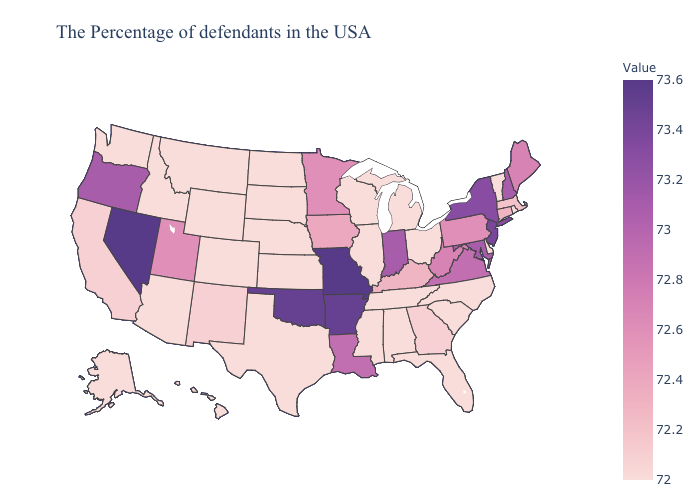Is the legend a continuous bar?
Give a very brief answer. Yes. Does Missouri have a lower value than Wisconsin?
Write a very short answer. No. Does Nebraska have a lower value than Kentucky?
Keep it brief. Yes. Which states have the lowest value in the USA?
Quick response, please. Rhode Island, Vermont, Delaware, North Carolina, South Carolina, Ohio, Florida, Michigan, Alabama, Tennessee, Wisconsin, Illinois, Mississippi, Kansas, Nebraska, Texas, South Dakota, North Dakota, Wyoming, Colorado, Montana, Arizona, Idaho, Washington, Alaska, Hawaii. 